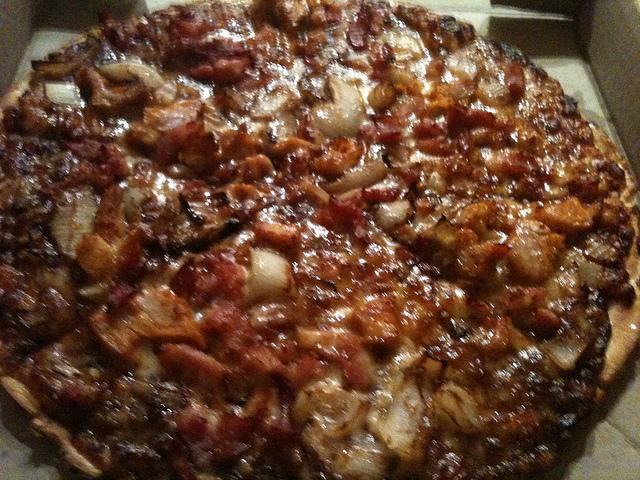How many pizzas are there?
Give a very brief answer. 1. How many bikes will fit on rack?
Give a very brief answer. 0. 